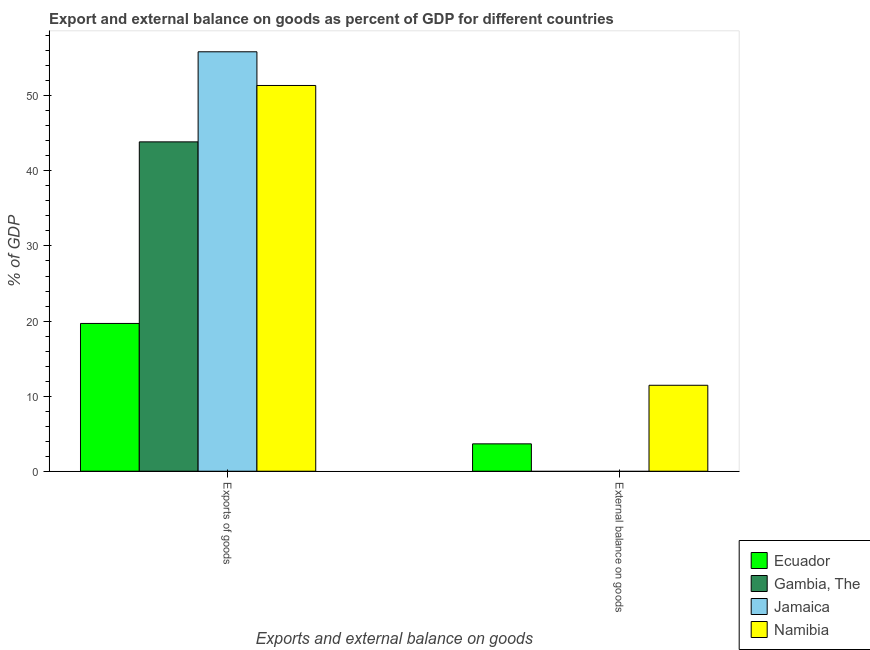How many different coloured bars are there?
Make the answer very short. 4. How many groups of bars are there?
Make the answer very short. 2. How many bars are there on the 1st tick from the right?
Offer a very short reply. 2. What is the label of the 1st group of bars from the left?
Your answer should be compact. Exports of goods. What is the export of goods as percentage of gdp in Ecuador?
Your response must be concise. 19.68. Across all countries, what is the maximum external balance on goods as percentage of gdp?
Keep it short and to the point. 11.45. Across all countries, what is the minimum export of goods as percentage of gdp?
Make the answer very short. 19.68. In which country was the external balance on goods as percentage of gdp maximum?
Your answer should be compact. Namibia. What is the total export of goods as percentage of gdp in the graph?
Offer a very short reply. 170.78. What is the difference between the export of goods as percentage of gdp in Ecuador and that in Jamaica?
Your response must be concise. -36.18. What is the difference between the external balance on goods as percentage of gdp in Gambia, The and the export of goods as percentage of gdp in Ecuador?
Give a very brief answer. -19.68. What is the average export of goods as percentage of gdp per country?
Your response must be concise. 42.7. What is the difference between the export of goods as percentage of gdp and external balance on goods as percentage of gdp in Ecuador?
Your answer should be compact. 16.04. What is the ratio of the export of goods as percentage of gdp in Ecuador to that in Jamaica?
Offer a terse response. 0.35. Is the export of goods as percentage of gdp in Jamaica less than that in Ecuador?
Provide a succinct answer. No. How many bars are there?
Provide a succinct answer. 6. Are the values on the major ticks of Y-axis written in scientific E-notation?
Your answer should be very brief. No. Does the graph contain any zero values?
Provide a short and direct response. Yes. Does the graph contain grids?
Offer a very short reply. No. What is the title of the graph?
Provide a succinct answer. Export and external balance on goods as percent of GDP for different countries. What is the label or title of the X-axis?
Ensure brevity in your answer.  Exports and external balance on goods. What is the label or title of the Y-axis?
Offer a terse response. % of GDP. What is the % of GDP of Ecuador in Exports of goods?
Your response must be concise. 19.68. What is the % of GDP of Gambia, The in Exports of goods?
Your answer should be compact. 43.86. What is the % of GDP in Jamaica in Exports of goods?
Offer a very short reply. 55.86. What is the % of GDP of Namibia in Exports of goods?
Offer a very short reply. 51.38. What is the % of GDP in Ecuador in External balance on goods?
Offer a very short reply. 3.65. What is the % of GDP of Jamaica in External balance on goods?
Keep it short and to the point. 0. What is the % of GDP of Namibia in External balance on goods?
Provide a succinct answer. 11.45. Across all Exports and external balance on goods, what is the maximum % of GDP of Ecuador?
Your response must be concise. 19.68. Across all Exports and external balance on goods, what is the maximum % of GDP in Gambia, The?
Keep it short and to the point. 43.86. Across all Exports and external balance on goods, what is the maximum % of GDP of Jamaica?
Your answer should be very brief. 55.86. Across all Exports and external balance on goods, what is the maximum % of GDP in Namibia?
Keep it short and to the point. 51.38. Across all Exports and external balance on goods, what is the minimum % of GDP of Ecuador?
Give a very brief answer. 3.65. Across all Exports and external balance on goods, what is the minimum % of GDP of Gambia, The?
Your answer should be very brief. 0. Across all Exports and external balance on goods, what is the minimum % of GDP of Jamaica?
Your answer should be compact. 0. Across all Exports and external balance on goods, what is the minimum % of GDP in Namibia?
Your answer should be compact. 11.45. What is the total % of GDP of Ecuador in the graph?
Provide a short and direct response. 23.33. What is the total % of GDP of Gambia, The in the graph?
Make the answer very short. 43.86. What is the total % of GDP of Jamaica in the graph?
Your answer should be compact. 55.86. What is the total % of GDP in Namibia in the graph?
Offer a terse response. 62.82. What is the difference between the % of GDP in Ecuador in Exports of goods and that in External balance on goods?
Provide a succinct answer. 16.04. What is the difference between the % of GDP in Namibia in Exports of goods and that in External balance on goods?
Offer a very short reply. 39.93. What is the difference between the % of GDP in Ecuador in Exports of goods and the % of GDP in Namibia in External balance on goods?
Your answer should be compact. 8.23. What is the difference between the % of GDP in Gambia, The in Exports of goods and the % of GDP in Namibia in External balance on goods?
Offer a terse response. 32.42. What is the difference between the % of GDP in Jamaica in Exports of goods and the % of GDP in Namibia in External balance on goods?
Offer a very short reply. 44.41. What is the average % of GDP of Ecuador per Exports and external balance on goods?
Your response must be concise. 11.66. What is the average % of GDP of Gambia, The per Exports and external balance on goods?
Your answer should be compact. 21.93. What is the average % of GDP of Jamaica per Exports and external balance on goods?
Your response must be concise. 27.93. What is the average % of GDP in Namibia per Exports and external balance on goods?
Your answer should be very brief. 31.41. What is the difference between the % of GDP in Ecuador and % of GDP in Gambia, The in Exports of goods?
Your answer should be compact. -24.18. What is the difference between the % of GDP of Ecuador and % of GDP of Jamaica in Exports of goods?
Your response must be concise. -36.18. What is the difference between the % of GDP in Ecuador and % of GDP in Namibia in Exports of goods?
Your response must be concise. -31.69. What is the difference between the % of GDP of Gambia, The and % of GDP of Jamaica in Exports of goods?
Your response must be concise. -12. What is the difference between the % of GDP in Gambia, The and % of GDP in Namibia in Exports of goods?
Give a very brief answer. -7.51. What is the difference between the % of GDP of Jamaica and % of GDP of Namibia in Exports of goods?
Keep it short and to the point. 4.49. What is the difference between the % of GDP of Ecuador and % of GDP of Namibia in External balance on goods?
Keep it short and to the point. -7.8. What is the ratio of the % of GDP of Ecuador in Exports of goods to that in External balance on goods?
Give a very brief answer. 5.4. What is the ratio of the % of GDP of Namibia in Exports of goods to that in External balance on goods?
Offer a very short reply. 4.49. What is the difference between the highest and the second highest % of GDP of Ecuador?
Ensure brevity in your answer.  16.04. What is the difference between the highest and the second highest % of GDP in Namibia?
Offer a very short reply. 39.93. What is the difference between the highest and the lowest % of GDP in Ecuador?
Offer a very short reply. 16.04. What is the difference between the highest and the lowest % of GDP of Gambia, The?
Your answer should be very brief. 43.86. What is the difference between the highest and the lowest % of GDP of Jamaica?
Give a very brief answer. 55.86. What is the difference between the highest and the lowest % of GDP of Namibia?
Make the answer very short. 39.93. 